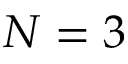<formula> <loc_0><loc_0><loc_500><loc_500>N = 3</formula> 